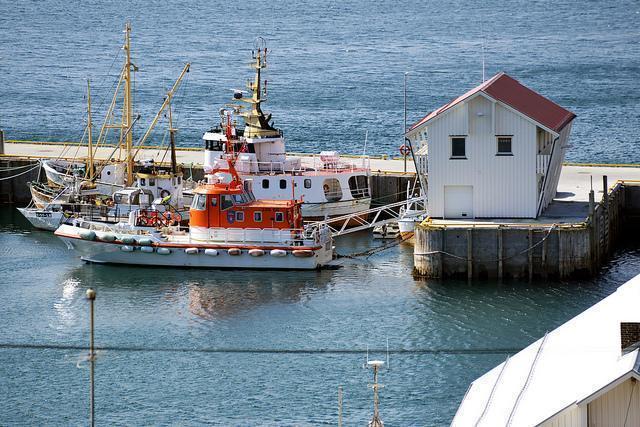What is above water?
Select the accurate answer and provide explanation: 'Answer: answer
Rationale: rationale.'
Options: Boat, swimmer, surfer, dolphin. Answer: boat.
Rationale: The boats are above water since they are docked and buoyed up. 